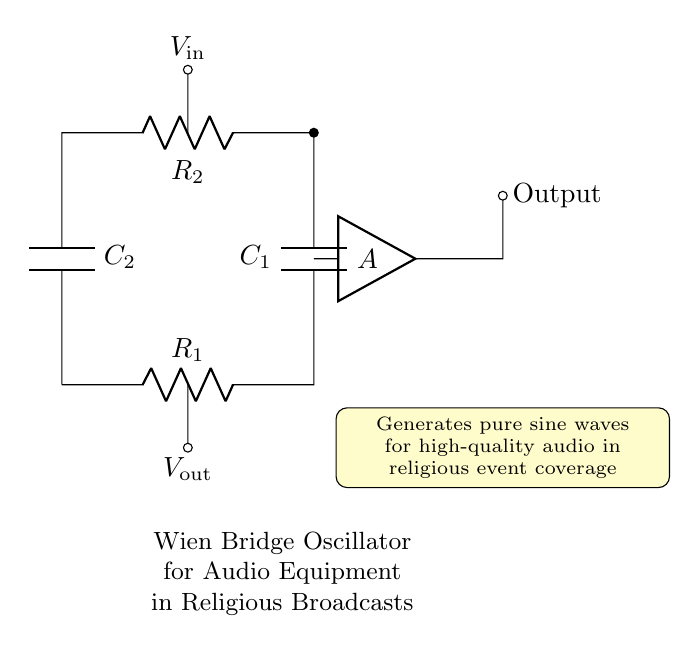What type of circuit is shown? The circuit is a Wien Bridge Oscillator, which is characterized by its ability to generate sine waves and is commonly used in audio applications.
Answer: Wien Bridge Oscillator What components are present in the circuit? The main components are two resistors R1 and R2, and two capacitors C1 and C2, which are essential for establishing the oscillation frequency and waveform shape.
Answer: Resistors and capacitors What is represented by the output node? The output node indicates where the output voltage is measured, which represents the sine wave generated by the oscillator.
Answer: Sine wave output How many resistors are in the circuit? There are two resistors, R1 and R2, which work in conjunction with the capacitors to set the conditions for oscillation.
Answer: Two resistors What is the function of the amplifier in the circuit? The amplifier, labeled A, is used to increase the amplitude of the oscillating signal, ensuring that the output is strong enough for audio transmission in broadcasts.
Answer: Amplification What role do the capacitors play in this circuit? The capacitors C1 and C2 are crucial for creating the frequency-determining network that allows for the stable generation of sine waves, affecting the oscillation frequency.
Answer: Frequency control What is the significance of generating pure sine waves for religious broadcasts? Generating pure sine waves ensures high audio quality, which is vital for clear communication during religious events, minimizing distortion that could interfere with the message.
Answer: High audio quality 